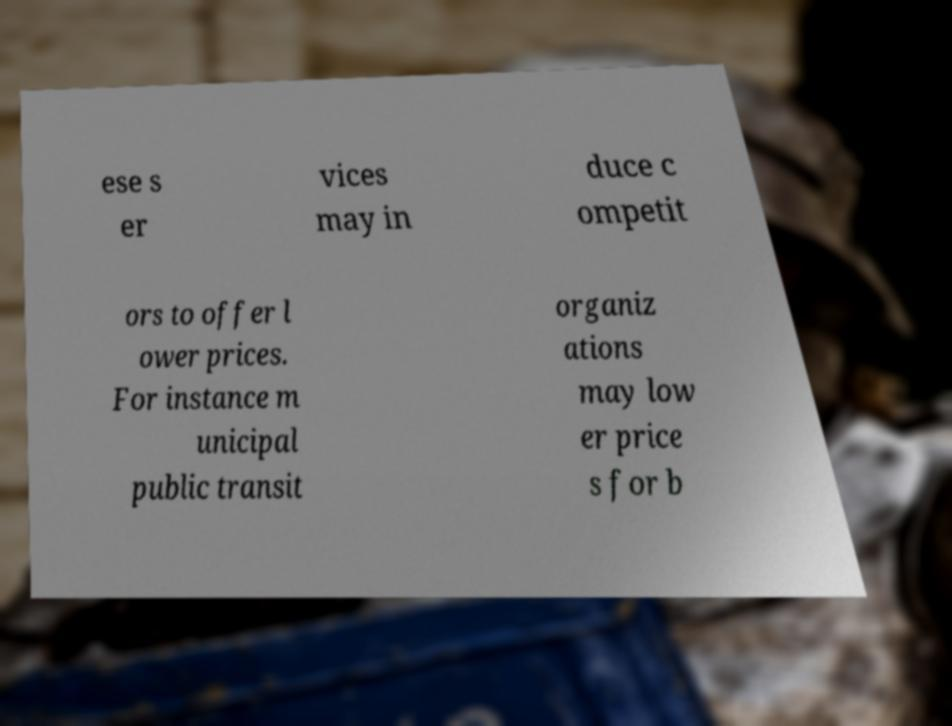What messages or text are displayed in this image? I need them in a readable, typed format. ese s er vices may in duce c ompetit ors to offer l ower prices. For instance m unicipal public transit organiz ations may low er price s for b 